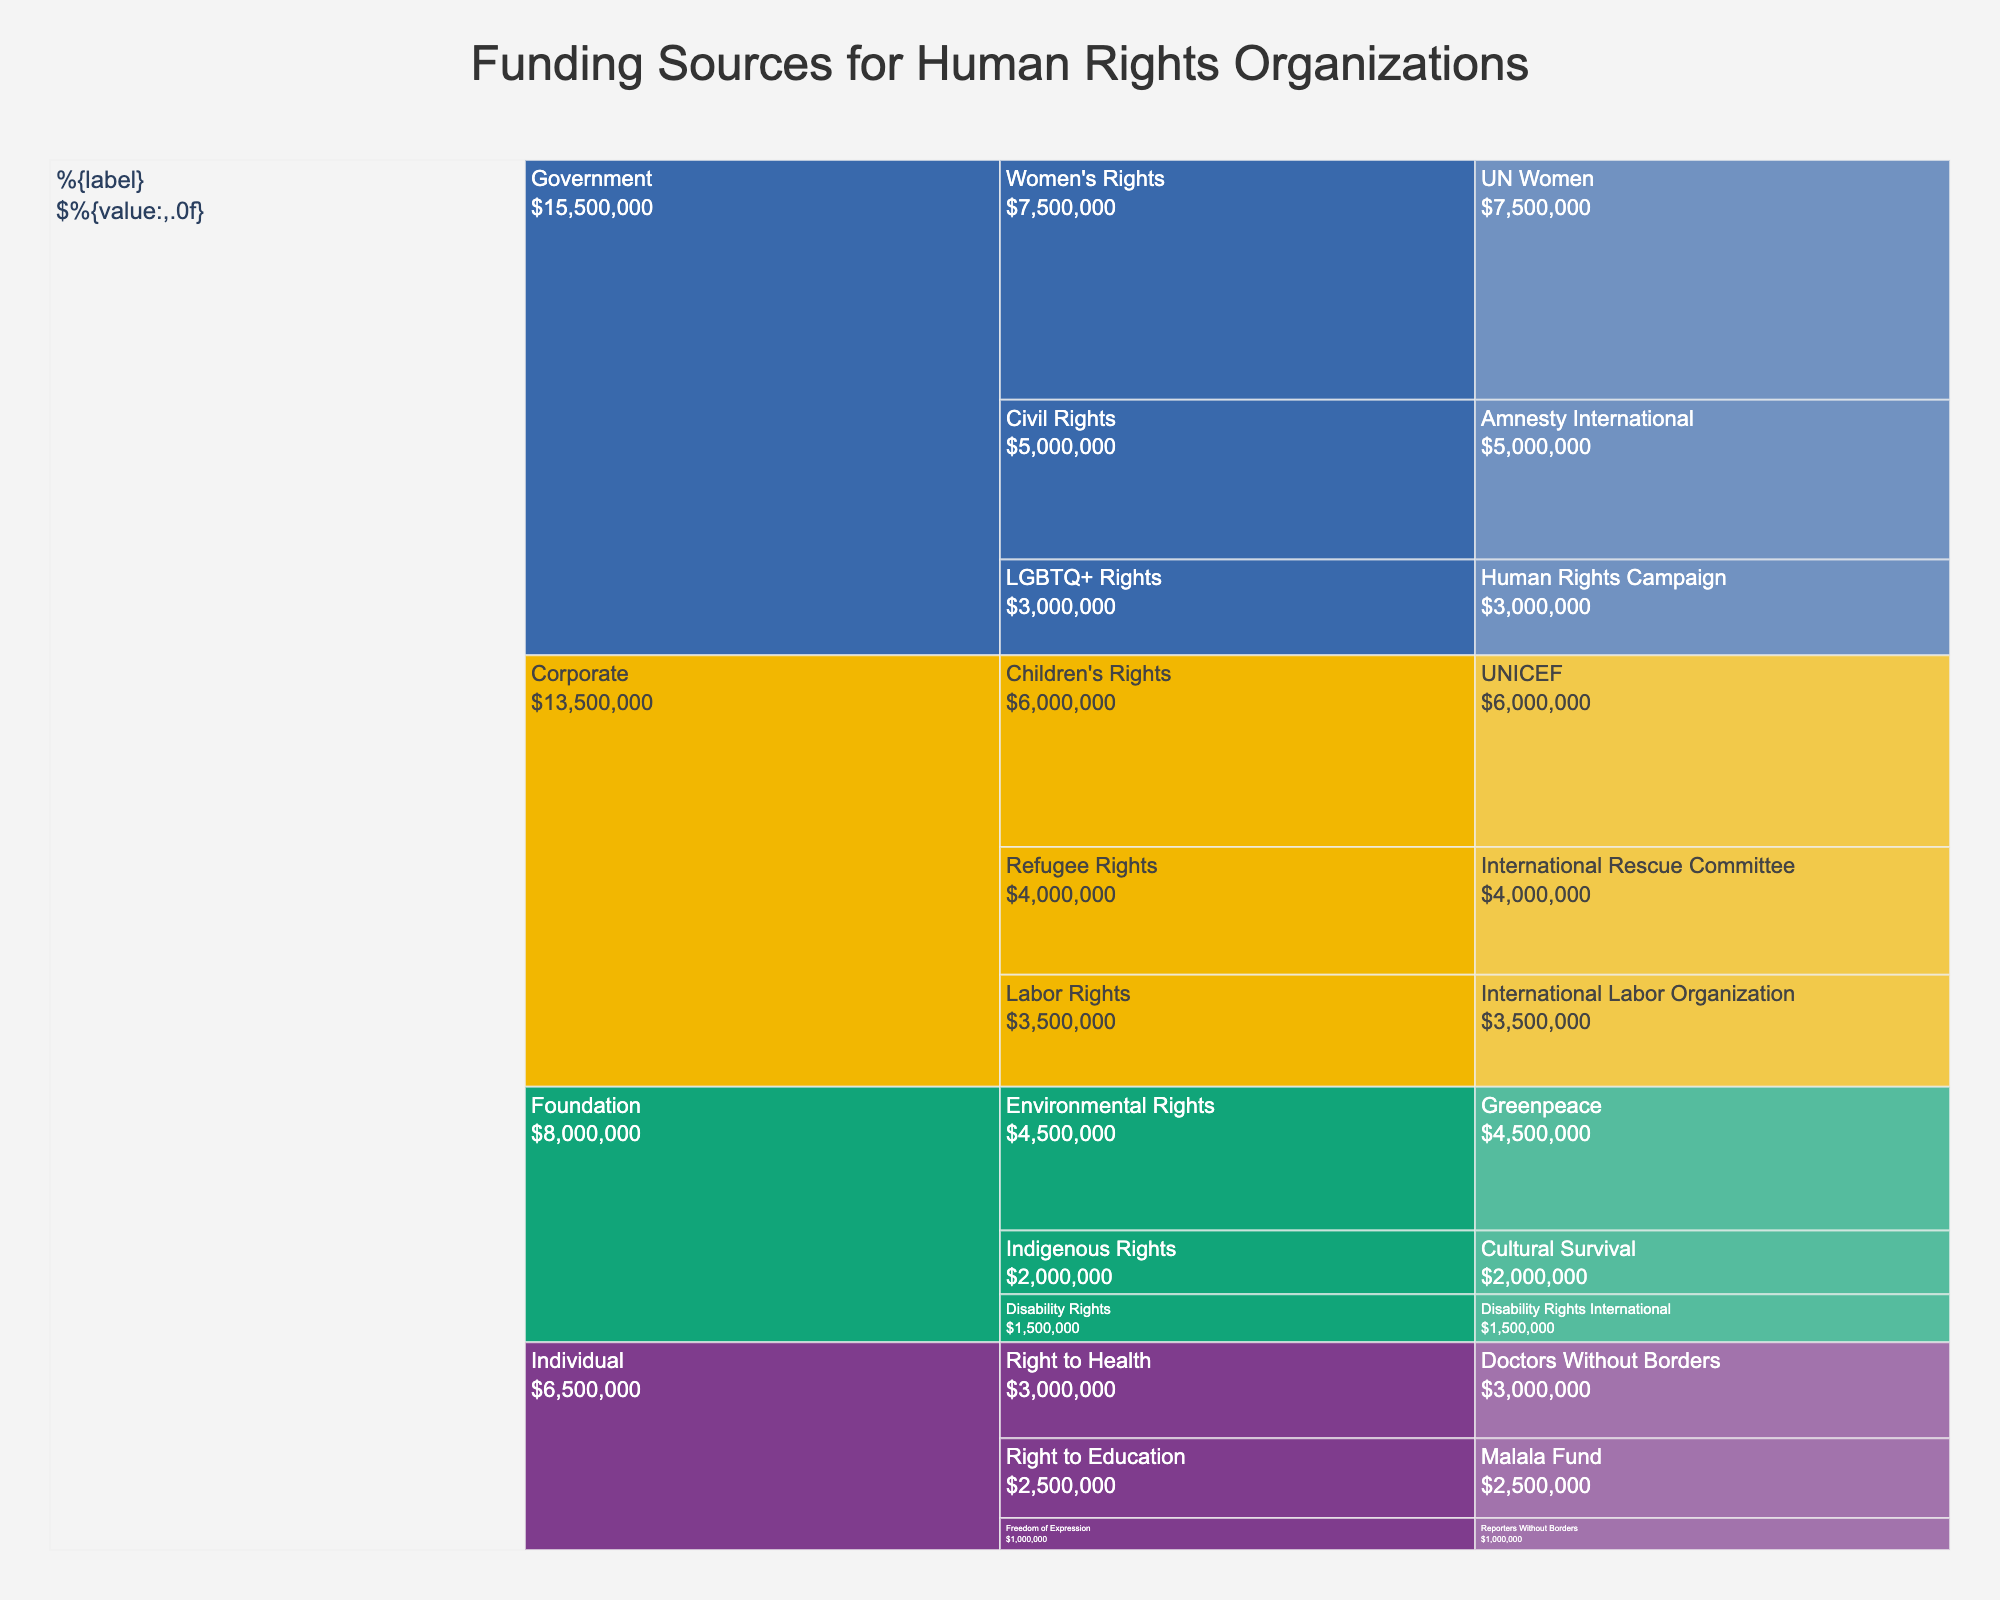What's the title of the figure? The title is usually located at the top of the figure and is typically larger in font size. In this case, it's prominently displayed as "Funding Sources for Human Rights Organizations".
Answer: Funding Sources for Human Rights Organizations How many donor types are there? By looking at the first layer or segment of the icicle chart, which highlights donor types, we can count the various colored sections representing each donor type.
Answer: Four Which program area received the most funding from government donors? By navigating through the government donor segment, we look at the program areas under its section, comparing the amounts to identify which received the highest funding.
Answer: Women's Rights Compare the amount of funding received by the International Rescue Committee and the International Labor Organization. Locate both organizations in the icicle chart, which fall under different donor types. Compare their respective funding amounts: $4,000,000 for the International Rescue Committee and $3,500,000 for the International Labor Organization.
Answer: The International Rescue Committee received more funding What is the total funding received by organizations under individual donors? Sum up the funding amounts for all organizations under the individual donor type: $1,000,000 (Reporters Without Borders) + $2,500,000 (Malala Fund) + $3,000,000 (Doctors Without Borders). This results in $6,500,000.
Answer: $6,500,000 Which donor type contributed the least amount of funding? Compare the total funding amounts across all donor types by summing the amounts associated with each type. Foundations contributed a total of $8,000,000, the least among the donor types.
Answer: Foundation How much more funding does UNICEF receive compared to Disability Rights International? Find the funding amounts for both organizations: UNICEF ($6,000,000) and Disability Rights International ($1,500,000). Calculate the difference: $6,000,000 - $1,500,000 = $4,500,000.
Answer: $4,500,000 List the organizations that received funding for Civil Rights. Navigate to the Civil Rights program area, under which the funded organizations are listed. In this case, it's Amnesty International.
Answer: Amnesty International Which program area under corporate donors received the highest funding? Examine the different branches under corporate donors, comparing the sums of funding amounts for each program area. The highest funding is for Children's Rights, with $6,000,000.
Answer: Children's Rights How many organizations are funded by individual donors? Count the number of unique organizations listed under the individual donor type by referring to the segments beneath it.
Answer: Three 